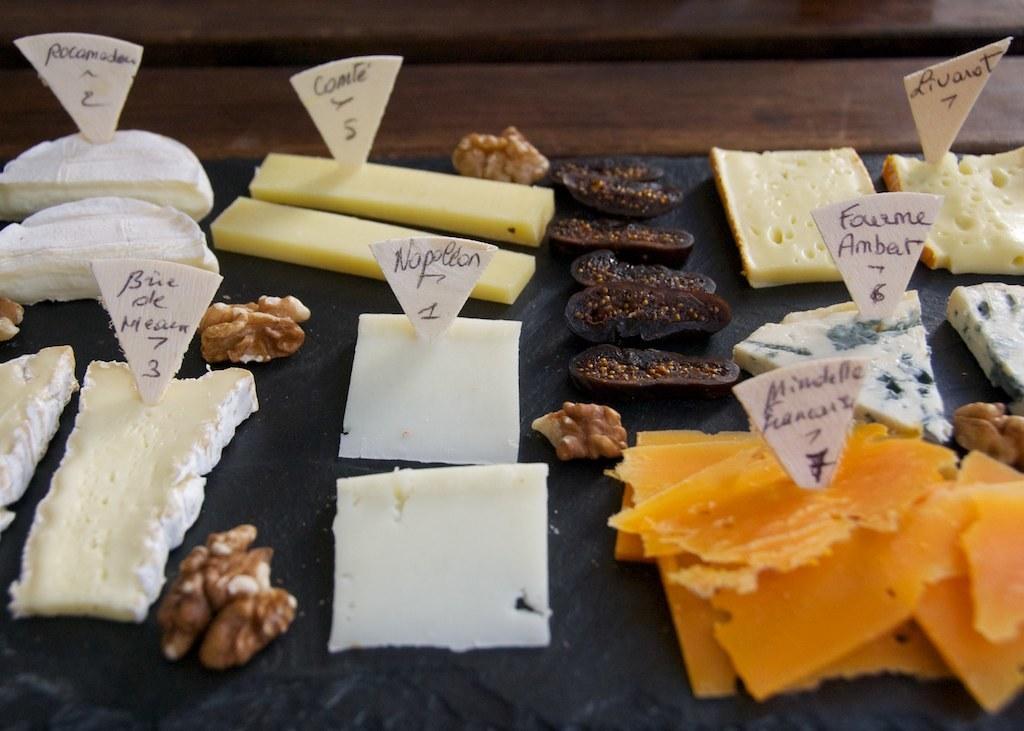In one or two sentences, can you explain what this image depicts? In this image there is food, there are boards with text on it, there is a wooden object towards the top of the image. 